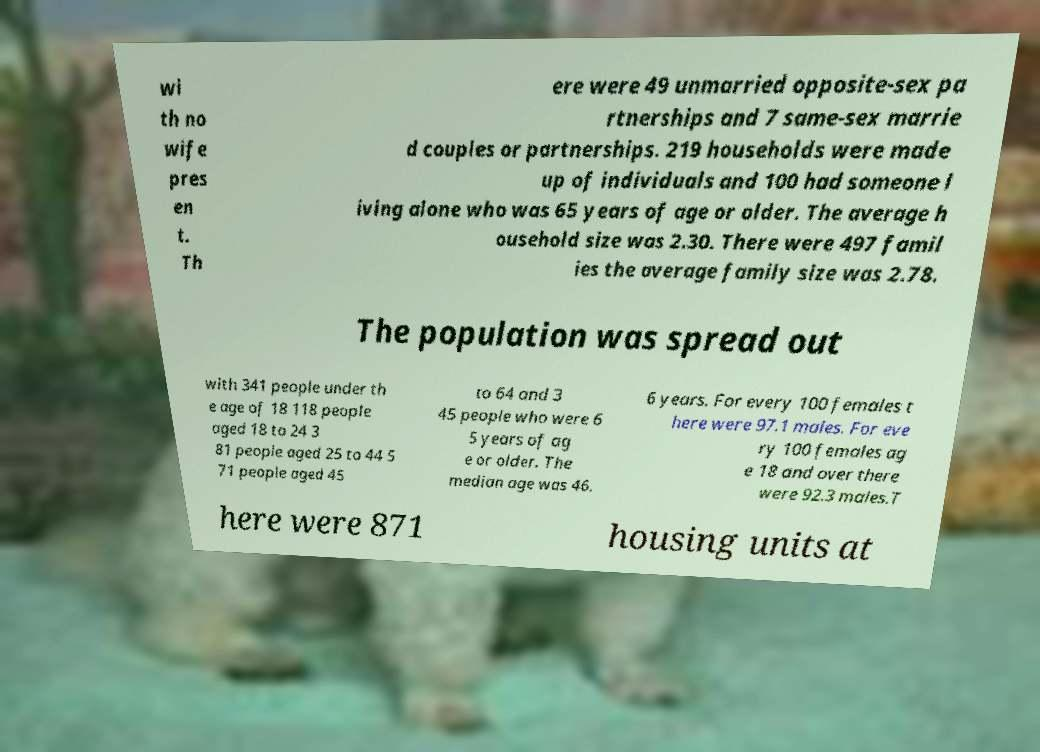Could you extract and type out the text from this image? wi th no wife pres en t. Th ere were 49 unmarried opposite-sex pa rtnerships and 7 same-sex marrie d couples or partnerships. 219 households were made up of individuals and 100 had someone l iving alone who was 65 years of age or older. The average h ousehold size was 2.30. There were 497 famil ies the average family size was 2.78. The population was spread out with 341 people under th e age of 18 118 people aged 18 to 24 3 81 people aged 25 to 44 5 71 people aged 45 to 64 and 3 45 people who were 6 5 years of ag e or older. The median age was 46. 6 years. For every 100 females t here were 97.1 males. For eve ry 100 females ag e 18 and over there were 92.3 males.T here were 871 housing units at 